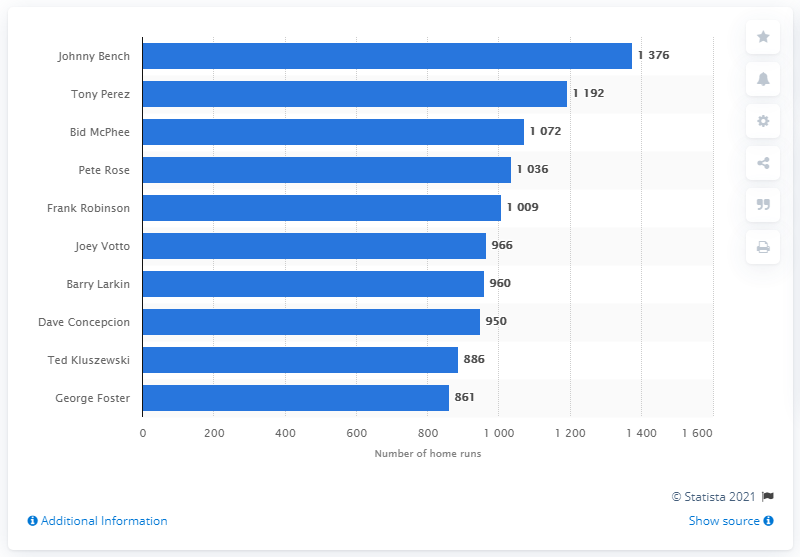List a handful of essential elements in this visual. The Cincinnati Reds franchise has produced many successful players throughout its history, but none more so than Johnny Bench, who holds the record for the most RBI in Reds franchise history. 